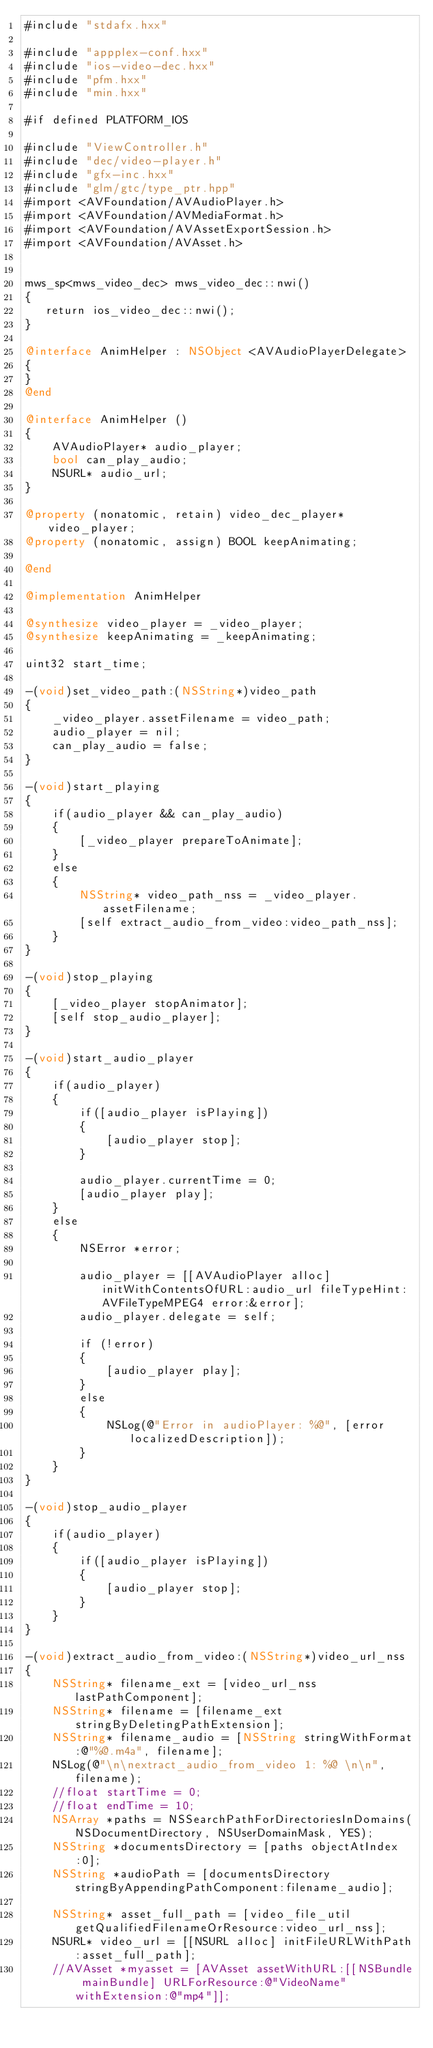<code> <loc_0><loc_0><loc_500><loc_500><_ObjectiveC_>#include "stdafx.hxx"

#include "appplex-conf.hxx"
#include "ios-video-dec.hxx"
#include "pfm.hxx"
#include "min.hxx"

#if defined PLATFORM_IOS

#include "ViewController.h"
#include "dec/video-player.h"
#include "gfx-inc.hxx"
#include "glm/gtc/type_ptr.hpp"
#import <AVFoundation/AVAudioPlayer.h>
#import <AVFoundation/AVMediaFormat.h>
#import <AVFoundation/AVAssetExportSession.h>
#import <AVFoundation/AVAsset.h>


mws_sp<mws_video_dec> mws_video_dec::nwi()
{
   return ios_video_dec::nwi();
}

@interface AnimHelper : NSObject <AVAudioPlayerDelegate>
{
}
@end

@interface AnimHelper ()
{
    AVAudioPlayer* audio_player;
    bool can_play_audio;
    NSURL* audio_url;
}

@property (nonatomic, retain) video_dec_player* video_player;
@property (nonatomic, assign) BOOL keepAnimating;

@end

@implementation AnimHelper

@synthesize video_player = _video_player;
@synthesize keepAnimating = _keepAnimating;

uint32 start_time;

-(void)set_video_path:(NSString*)video_path
{
    _video_player.assetFilename = video_path;
    audio_player = nil;
    can_play_audio = false;
}

-(void)start_playing
{
    if(audio_player && can_play_audio)
    {
        [_video_player prepareToAnimate];
    }
    else
    {
        NSString* video_path_nss = _video_player.assetFilename;
        [self extract_audio_from_video:video_path_nss];
    }
}

-(void)stop_playing
{
    [_video_player stopAnimator];
    [self stop_audio_player];
}

-(void)start_audio_player
{
    if(audio_player)
    {
        if([audio_player isPlaying])
        {
            [audio_player stop];
        }
        
        audio_player.currentTime = 0;
        [audio_player play];
    }
    else
    {
        NSError *error;
        
        audio_player = [[AVAudioPlayer alloc] initWithContentsOfURL:audio_url fileTypeHint:AVFileTypeMPEG4 error:&error];
        audio_player.delegate = self;
        
        if (!error)
        {
            [audio_player play];
        }
        else
        {
            NSLog(@"Error in audioPlayer: %@", [error localizedDescription]);
        }
    }
}

-(void)stop_audio_player
{
    if(audio_player)
    {
        if([audio_player isPlaying])
        {
            [audio_player stop];
        }
    }
}

-(void)extract_audio_from_video:(NSString*)video_url_nss
{
    NSString* filename_ext = [video_url_nss lastPathComponent];
    NSString* filename = [filename_ext stringByDeletingPathExtension];
    NSString* filename_audio = [NSString stringWithFormat:@"%@.m4a", filename];
    NSLog(@"\n\nextract_audio_from_video 1: %@ \n\n", filename);
    //float startTime = 0;
    //float endTime = 10;
    NSArray *paths = NSSearchPathForDirectoriesInDomains(NSDocumentDirectory, NSUserDomainMask, YES);
    NSString *documentsDirectory = [paths objectAtIndex:0];
    NSString *audioPath = [documentsDirectory stringByAppendingPathComponent:filename_audio];
    
    NSString* asset_full_path = [video_file_util getQualifiedFilenameOrResource:video_url_nss];
    NSURL* video_url = [[NSURL alloc] initFileURLWithPath:asset_full_path];
    //AVAsset *myasset = [AVAsset assetWithURL:[[NSBundle mainBundle] URLForResource:@"VideoName" withExtension:@"mp4"]];</code> 